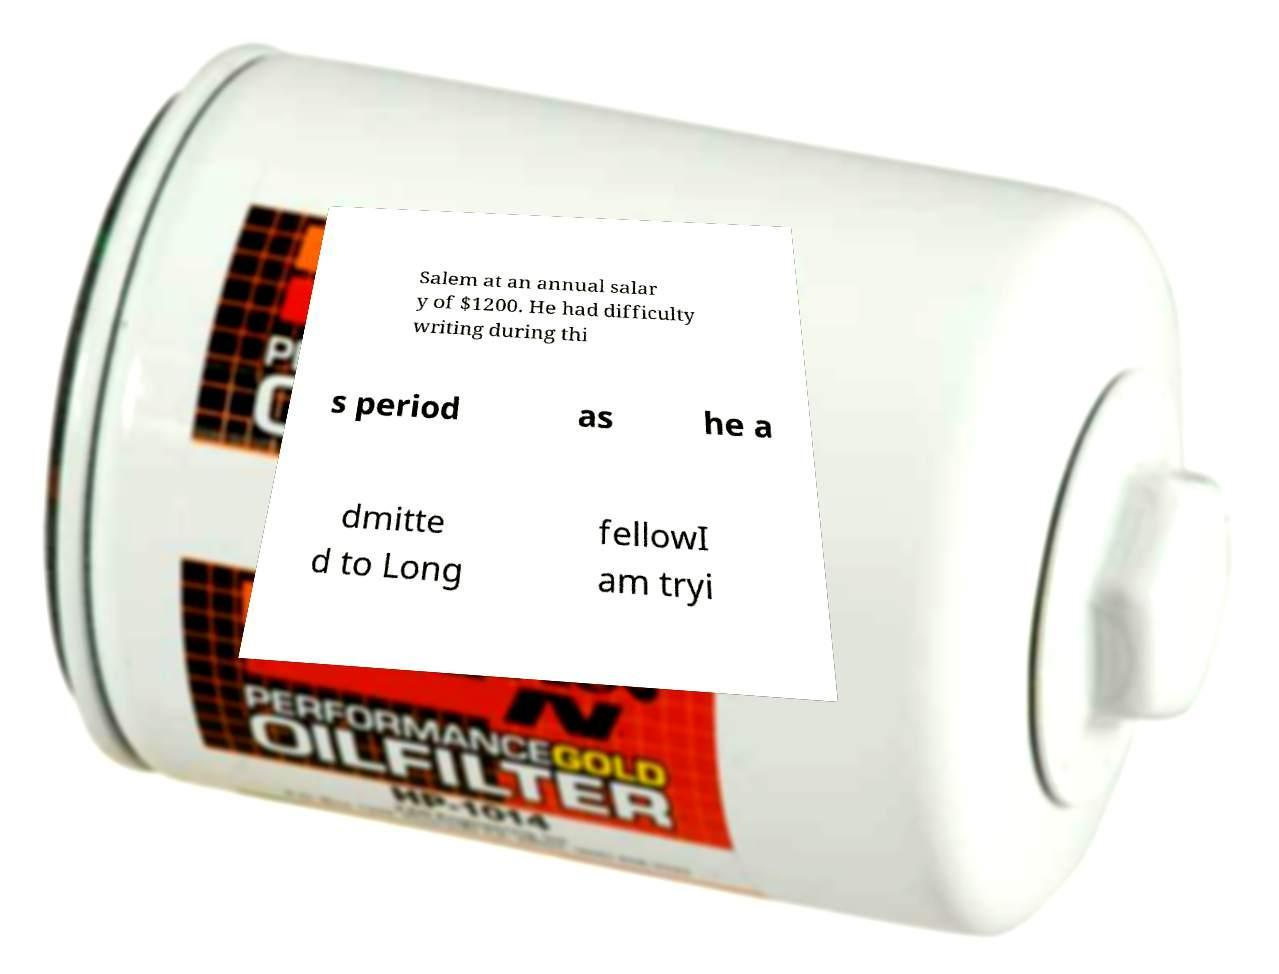Could you extract and type out the text from this image? Salem at an annual salar y of $1200. He had difficulty writing during thi s period as he a dmitte d to Long fellowI am tryi 